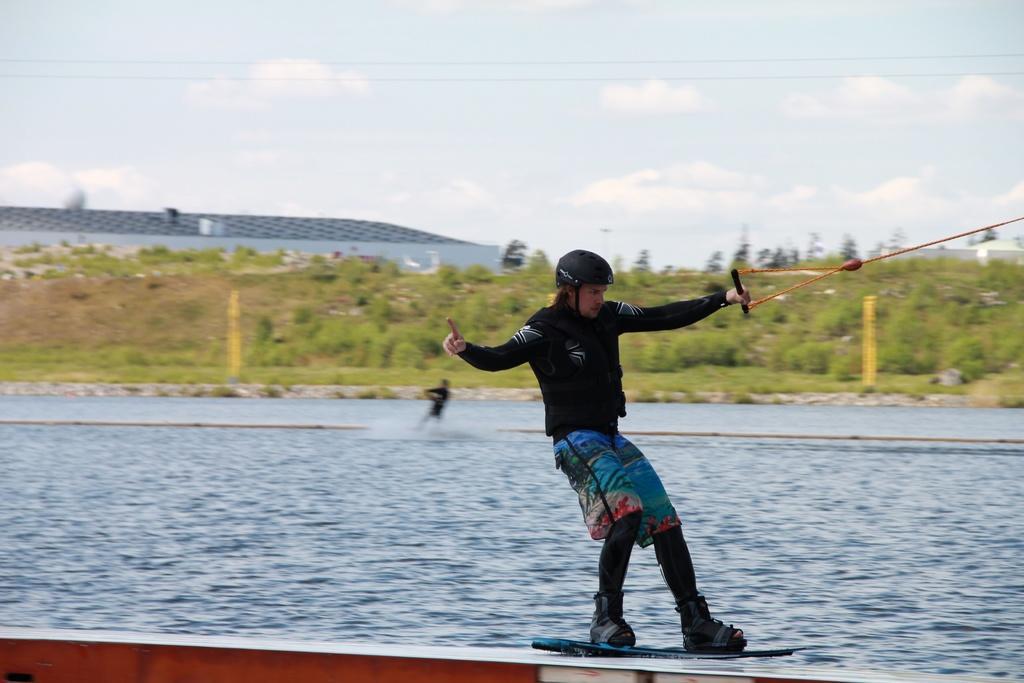How would you summarize this image in a sentence or two? In this picture we can see two persons, they are performing kitesurfing on the water, in the background we can see few trees, buildings and clouds. 